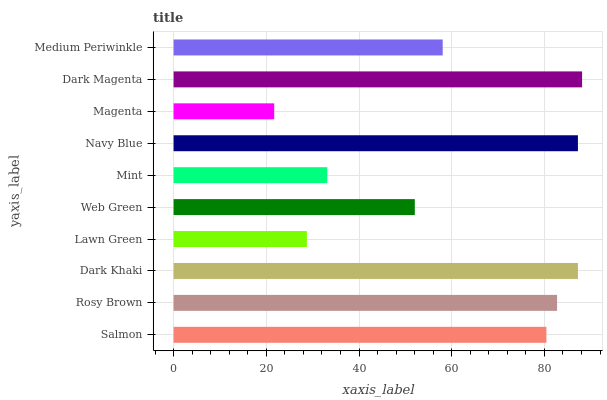Is Magenta the minimum?
Answer yes or no. Yes. Is Dark Magenta the maximum?
Answer yes or no. Yes. Is Rosy Brown the minimum?
Answer yes or no. No. Is Rosy Brown the maximum?
Answer yes or no. No. Is Rosy Brown greater than Salmon?
Answer yes or no. Yes. Is Salmon less than Rosy Brown?
Answer yes or no. Yes. Is Salmon greater than Rosy Brown?
Answer yes or no. No. Is Rosy Brown less than Salmon?
Answer yes or no. No. Is Salmon the high median?
Answer yes or no. Yes. Is Medium Periwinkle the low median?
Answer yes or no. Yes. Is Navy Blue the high median?
Answer yes or no. No. Is Rosy Brown the low median?
Answer yes or no. No. 